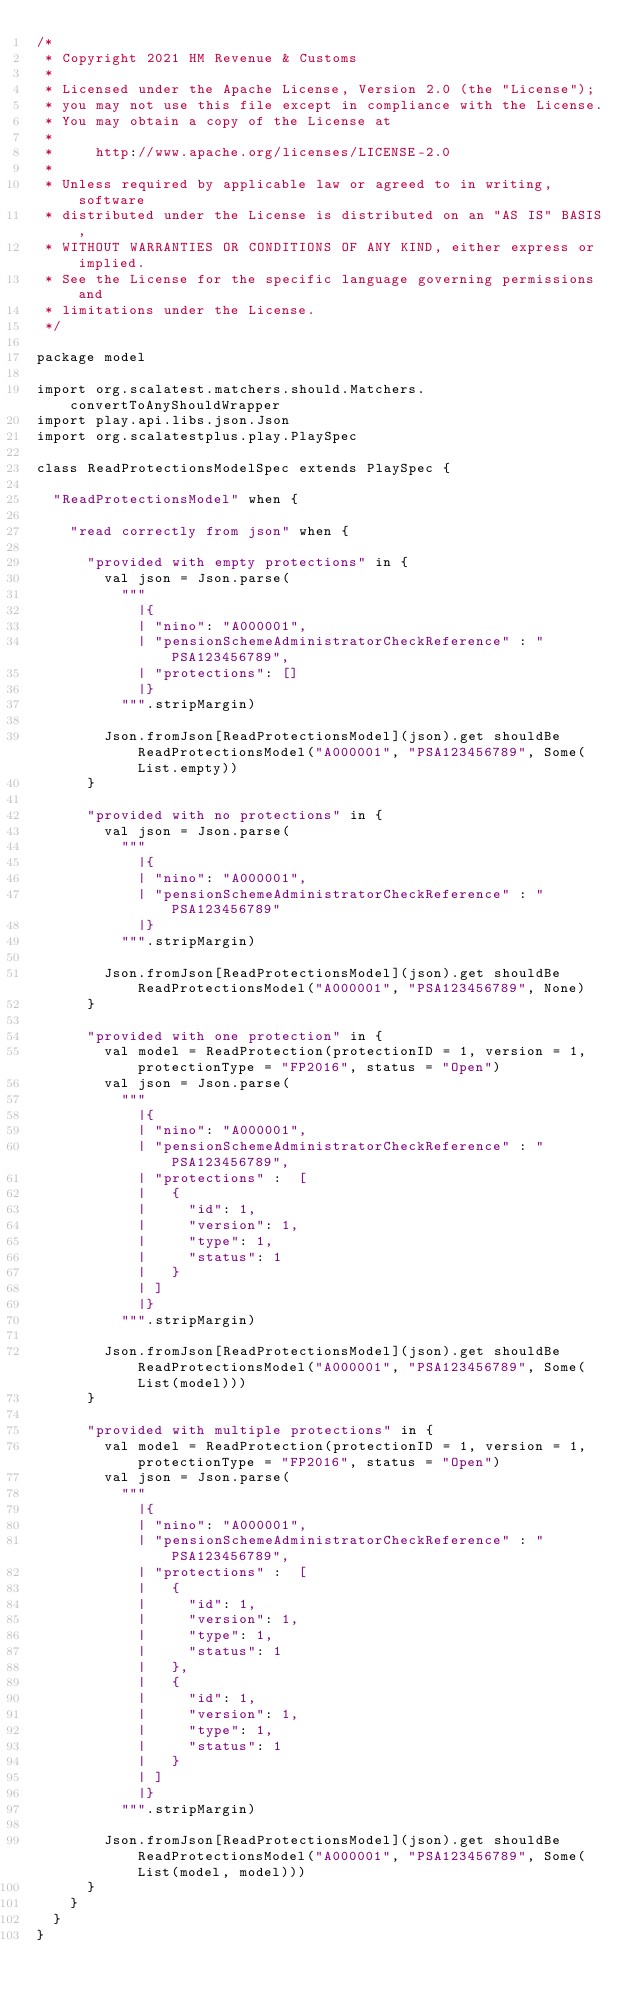<code> <loc_0><loc_0><loc_500><loc_500><_Scala_>/*
 * Copyright 2021 HM Revenue & Customs
 *
 * Licensed under the Apache License, Version 2.0 (the "License");
 * you may not use this file except in compliance with the License.
 * You may obtain a copy of the License at
 *
 *     http://www.apache.org/licenses/LICENSE-2.0
 *
 * Unless required by applicable law or agreed to in writing, software
 * distributed under the License is distributed on an "AS IS" BASIS,
 * WITHOUT WARRANTIES OR CONDITIONS OF ANY KIND, either express or implied.
 * See the License for the specific language governing permissions and
 * limitations under the License.
 */

package model

import org.scalatest.matchers.should.Matchers.convertToAnyShouldWrapper
import play.api.libs.json.Json
import org.scalatestplus.play.PlaySpec

class ReadProtectionsModelSpec extends PlaySpec {

  "ReadProtectionsModel" when {

    "read correctly from json" when {

      "provided with empty protections" in {
        val json = Json.parse(
          """
            |{
            | "nino": "A000001",
            | "pensionSchemeAdministratorCheckReference" : "PSA123456789",
            | "protections": []
            |}
          """.stripMargin)

        Json.fromJson[ReadProtectionsModel](json).get shouldBe ReadProtectionsModel("A000001", "PSA123456789", Some(List.empty))
      }

      "provided with no protections" in {
        val json = Json.parse(
          """
            |{
            | "nino": "A000001",
            | "pensionSchemeAdministratorCheckReference" : "PSA123456789"
            |}
          """.stripMargin)

        Json.fromJson[ReadProtectionsModel](json).get shouldBe ReadProtectionsModel("A000001", "PSA123456789", None)
      }

      "provided with one protection" in {
        val model = ReadProtection(protectionID = 1, version = 1, protectionType = "FP2016", status = "Open")
        val json = Json.parse(
          """
            |{
            | "nino": "A000001",
            | "pensionSchemeAdministratorCheckReference" : "PSA123456789",
            | "protections" :  [
            |   {
            |     "id": 1,
            |     "version": 1,
            |     "type": 1,
            |     "status": 1
            |   }
            | ]
            |}
          """.stripMargin)

        Json.fromJson[ReadProtectionsModel](json).get shouldBe ReadProtectionsModel("A000001", "PSA123456789", Some(List(model)))
      }

      "provided with multiple protections" in {
        val model = ReadProtection(protectionID = 1, version = 1, protectionType = "FP2016", status = "Open")
        val json = Json.parse(
          """
            |{
            | "nino": "A000001",
            | "pensionSchemeAdministratorCheckReference" : "PSA123456789",
            | "protections" :  [
            |   {
            |     "id": 1,
            |     "version": 1,
            |     "type": 1,
            |     "status": 1
            |   },
            |   {
            |     "id": 1,
            |     "version": 1,
            |     "type": 1,
            |     "status": 1
            |   }
            | ]
            |}
          """.stripMargin)

        Json.fromJson[ReadProtectionsModel](json).get shouldBe ReadProtectionsModel("A000001", "PSA123456789", Some(List(model, model)))
      }
    }
  }
}
</code> 